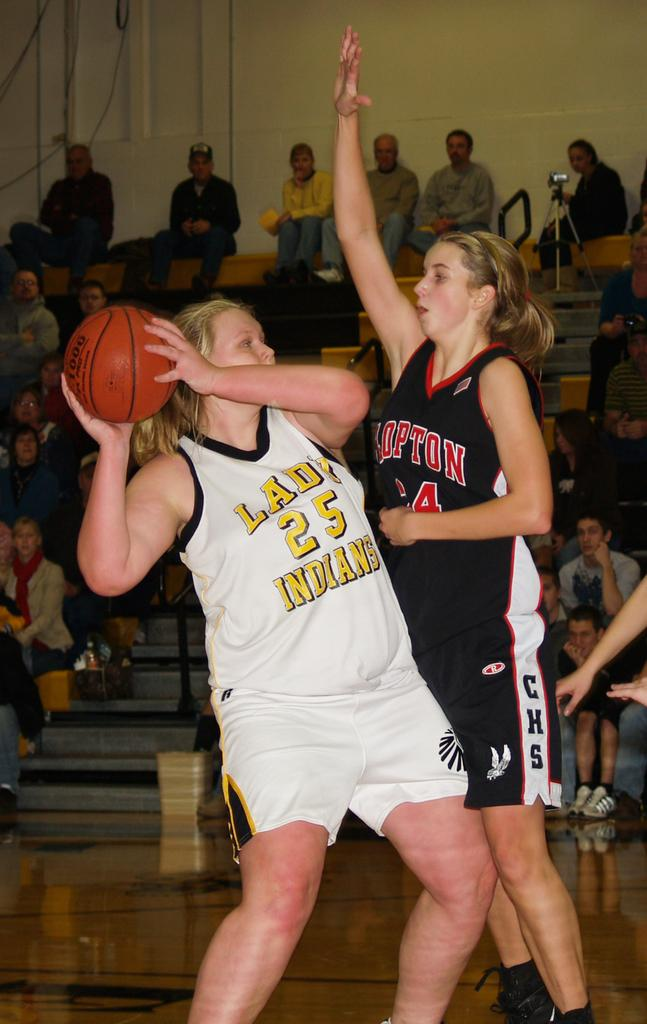Provide a one-sentence caption for the provided image. Two female basketball players are fighting over the ball and the player with the ball's jersey say Indians. 